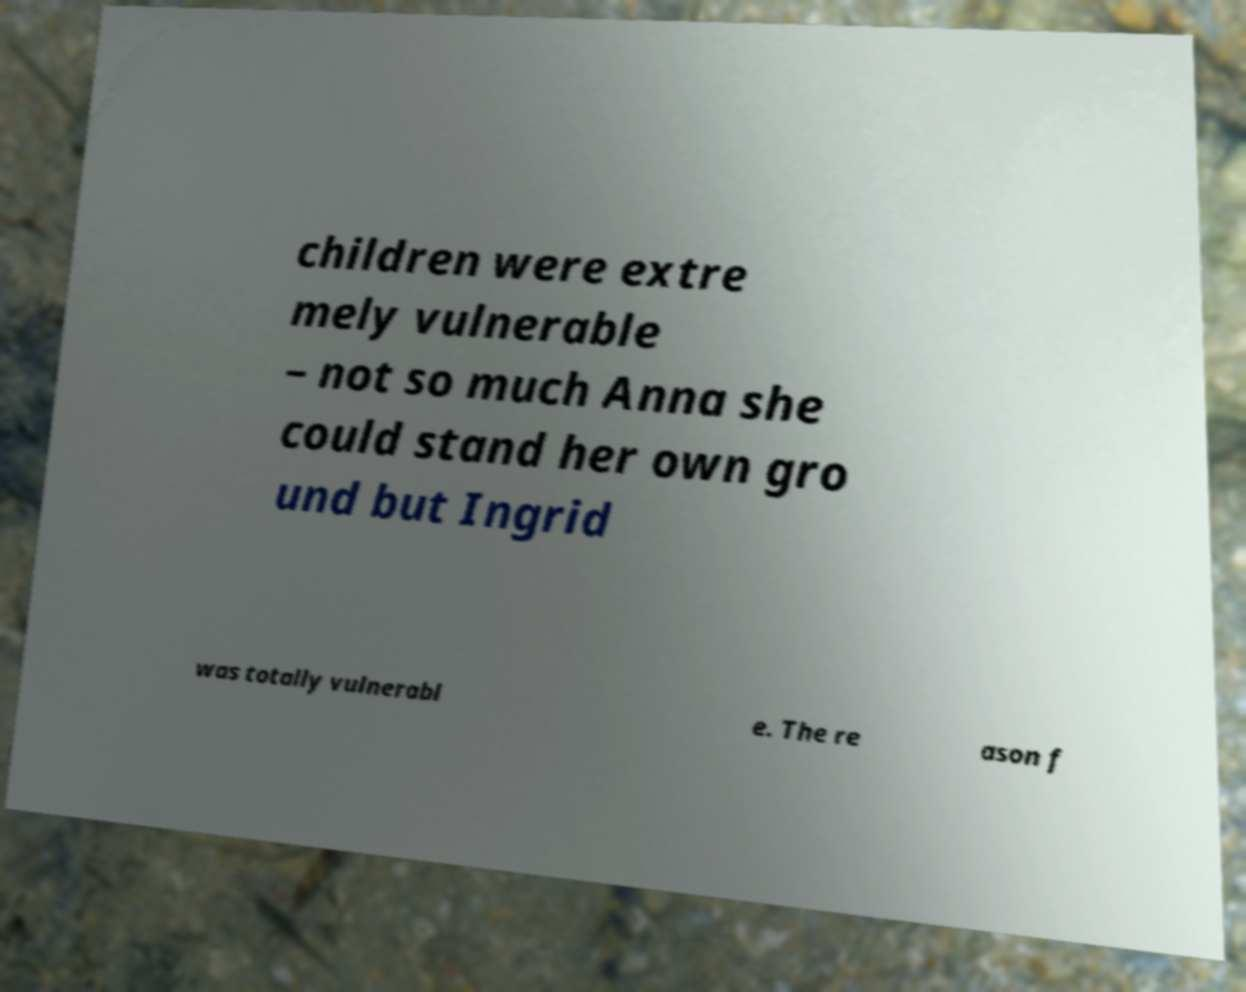There's text embedded in this image that I need extracted. Can you transcribe it verbatim? children were extre mely vulnerable – not so much Anna she could stand her own gro und but Ingrid was totally vulnerabl e. The re ason f 